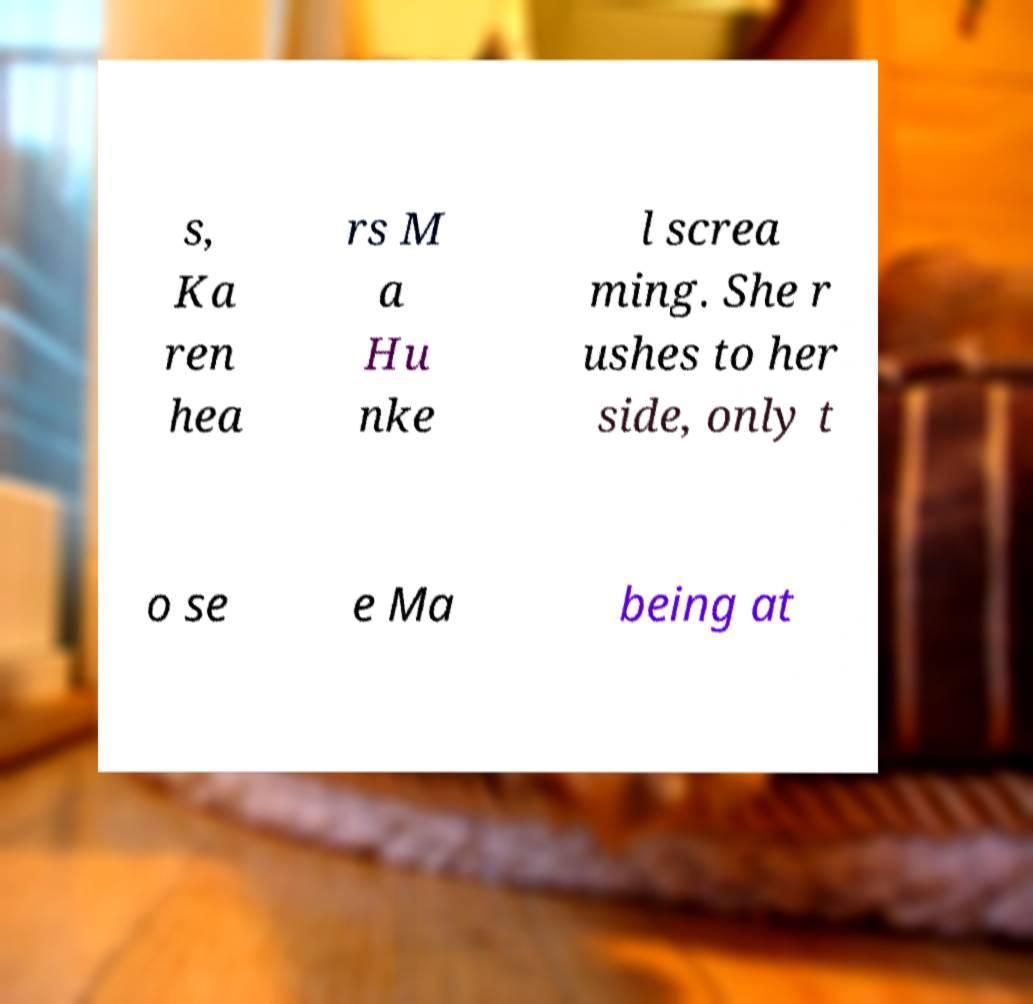Could you assist in decoding the text presented in this image and type it out clearly? s, Ka ren hea rs M a Hu nke l screa ming. She r ushes to her side, only t o se e Ma being at 